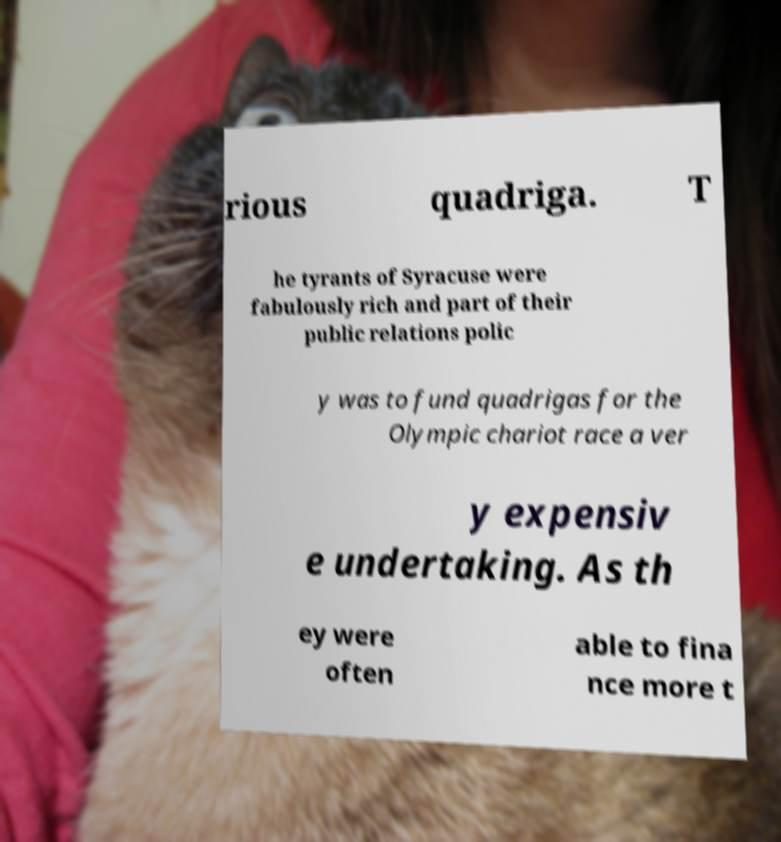Can you read and provide the text displayed in the image?This photo seems to have some interesting text. Can you extract and type it out for me? rious quadriga. T he tyrants of Syracuse were fabulously rich and part of their public relations polic y was to fund quadrigas for the Olympic chariot race a ver y expensiv e undertaking. As th ey were often able to fina nce more t 